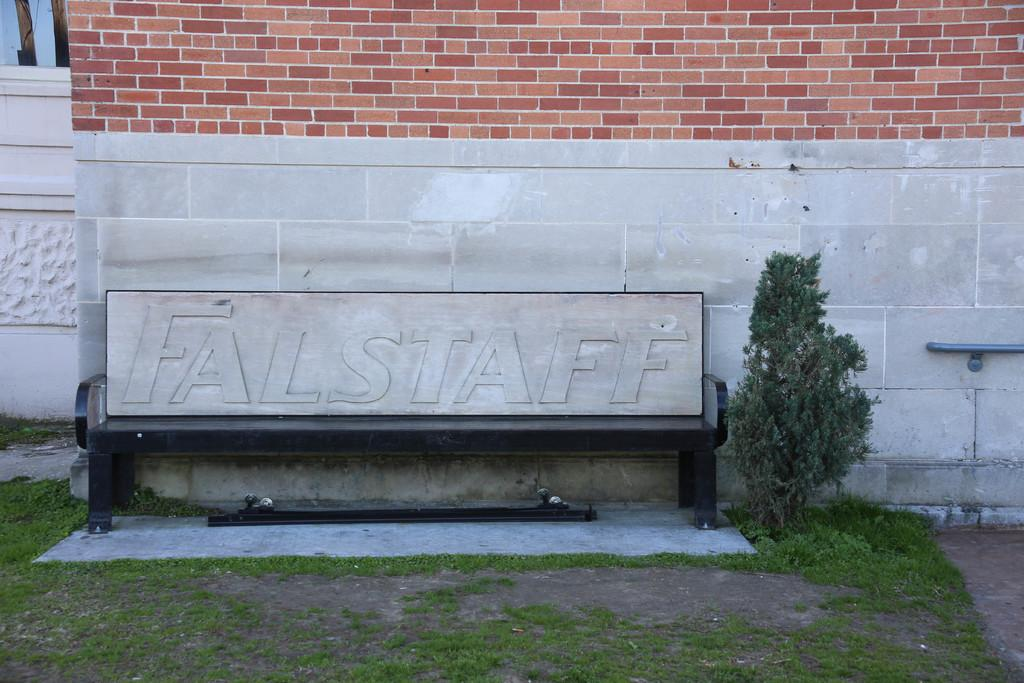What type of living organism can be seen in the image? There is a plant in the image. What is the background of the plant in the image? There is a brick wall near the plant. What type of vegetation is at the bottom of the image? There is grass at the bottom of the image. What brand of toothpaste is being advertised on the plant in the image? There is no toothpaste or advertisement present in the image; it features a plant and a brick wall. 